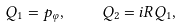<formula> <loc_0><loc_0><loc_500><loc_500>Q _ { 1 } = p _ { \varphi } , \quad Q _ { 2 } = i R Q _ { 1 } ,</formula> 